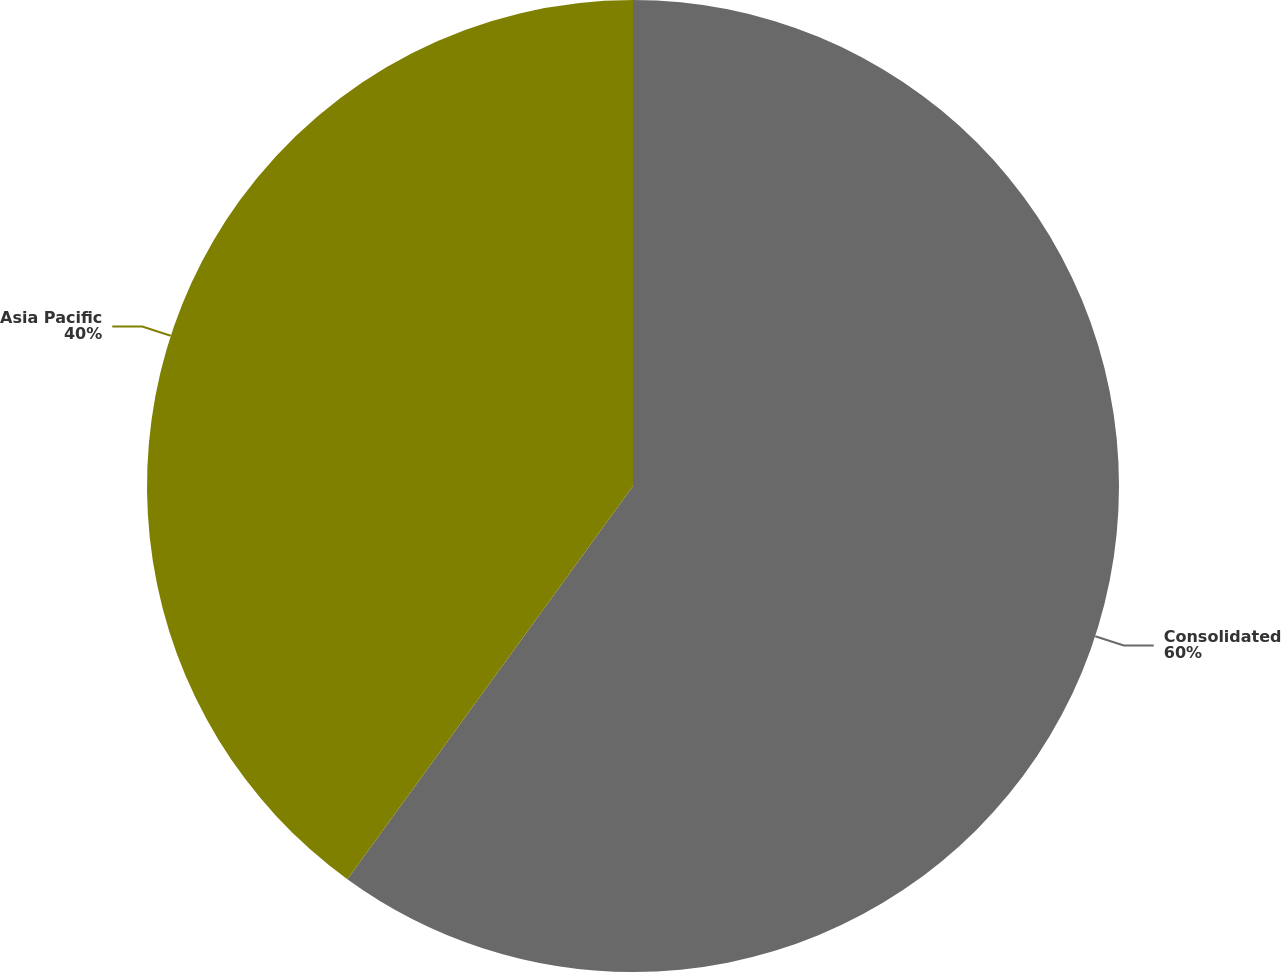Convert chart to OTSL. <chart><loc_0><loc_0><loc_500><loc_500><pie_chart><fcel>Consolidated<fcel>Asia Pacific<nl><fcel>60.0%<fcel>40.0%<nl></chart> 